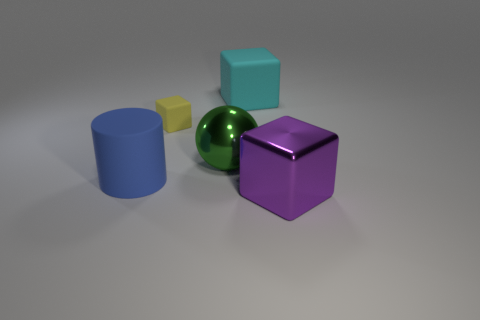Are there more large matte blocks than metallic things?
Your answer should be compact. No. How many things are rubber blocks in front of the big cyan rubber block or big blocks?
Your answer should be very brief. 3. Do the ball and the big cyan cube have the same material?
Make the answer very short. No. There is a purple shiny thing that is the same shape as the small rubber object; what is its size?
Your answer should be compact. Large. There is a shiny object in front of the matte cylinder; does it have the same shape as the large rubber thing that is on the left side of the yellow matte object?
Give a very brief answer. No. There is a yellow block; is its size the same as the shiny thing that is on the right side of the metal sphere?
Your answer should be compact. No. What number of other things are the same material as the green ball?
Your answer should be very brief. 1. Are there any other things that are the same shape as the yellow rubber thing?
Your answer should be compact. Yes. The big cube that is behind the metal object that is right of the large cube that is left of the metallic block is what color?
Your answer should be very brief. Cyan. What shape is the object that is both in front of the green shiny object and behind the big metal cube?
Make the answer very short. Cylinder. 